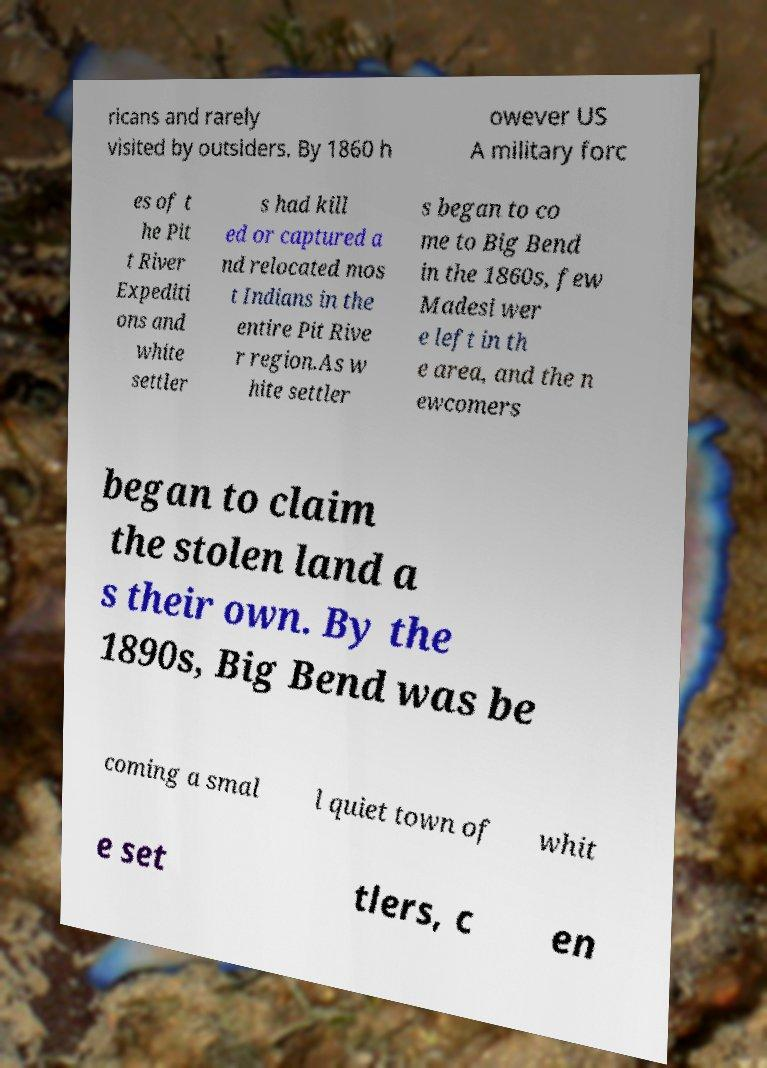Could you assist in decoding the text presented in this image and type it out clearly? ricans and rarely visited by outsiders. By 1860 h owever US A military forc es of t he Pit t River Expediti ons and white settler s had kill ed or captured a nd relocated mos t Indians in the entire Pit Rive r region.As w hite settler s began to co me to Big Bend in the 1860s, few Madesi wer e left in th e area, and the n ewcomers began to claim the stolen land a s their own. By the 1890s, Big Bend was be coming a smal l quiet town of whit e set tlers, c en 